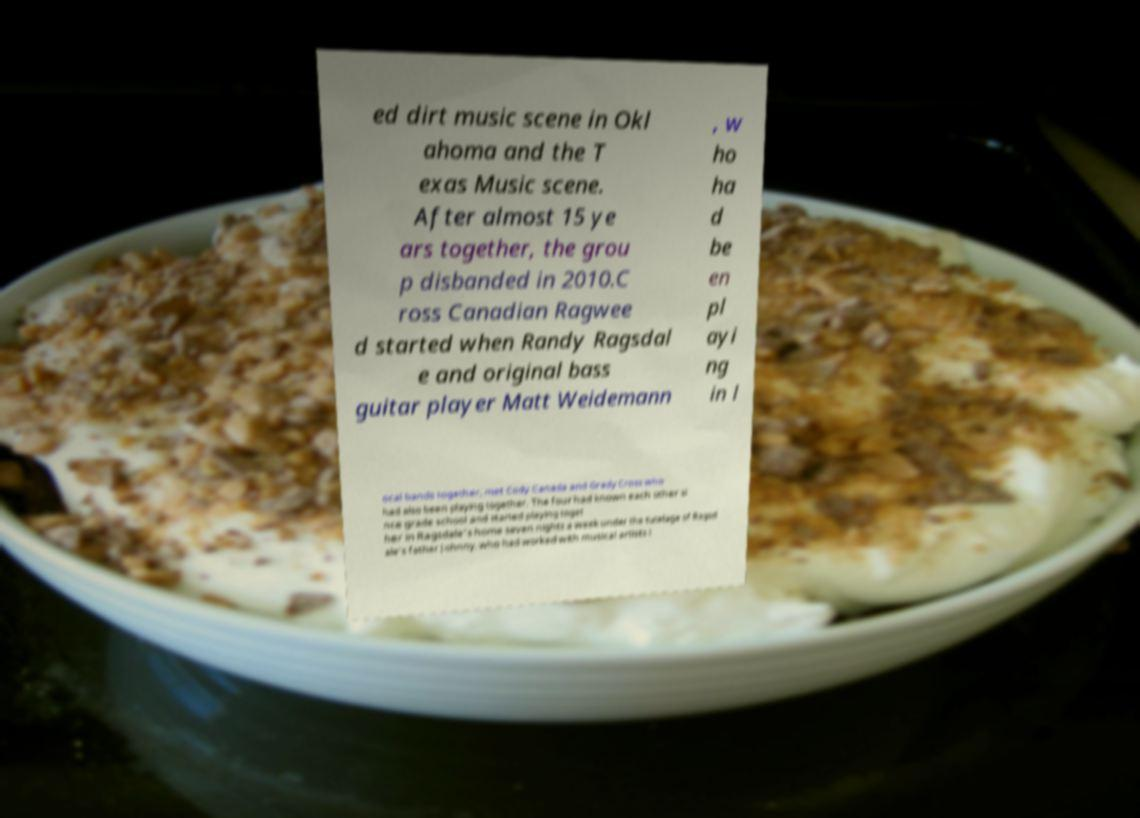Can you read and provide the text displayed in the image?This photo seems to have some interesting text. Can you extract and type it out for me? ed dirt music scene in Okl ahoma and the T exas Music scene. After almost 15 ye ars together, the grou p disbanded in 2010.C ross Canadian Ragwee d started when Randy Ragsdal e and original bass guitar player Matt Weidemann , w ho ha d be en pl ayi ng in l ocal bands together, met Cody Canada and Grady Cross who had also been playing together. The four had known each other si nce grade school and started playing toget her in Ragsdale's home seven nights a week under the tutelage of Ragsd ale's father Johnny, who had worked with musical artists i 